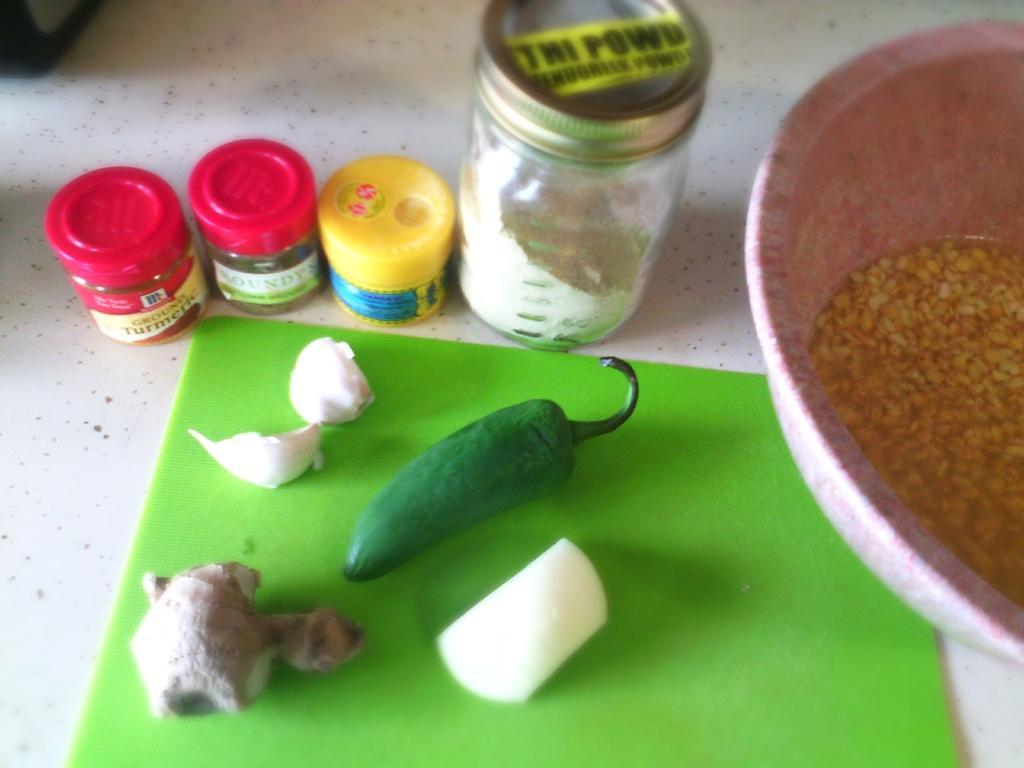Could you give a brief overview of what you see in this image? In this image, we can see green chilli, garlic, ginger and an onion. In the background, there are jars and there is a bowl with grains. 